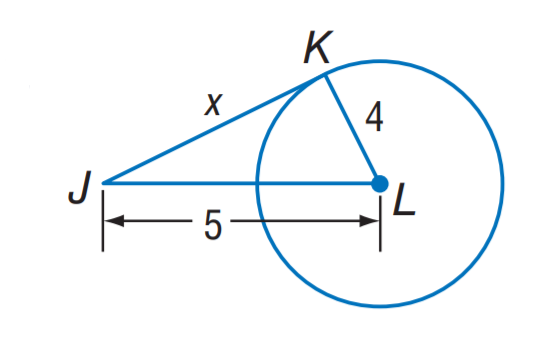Answer the mathemtical geometry problem and directly provide the correct option letter.
Question: The segment is tangent to the circle. Find x.
Choices: A: 2 B: 3 C: 4 D: 5 B 